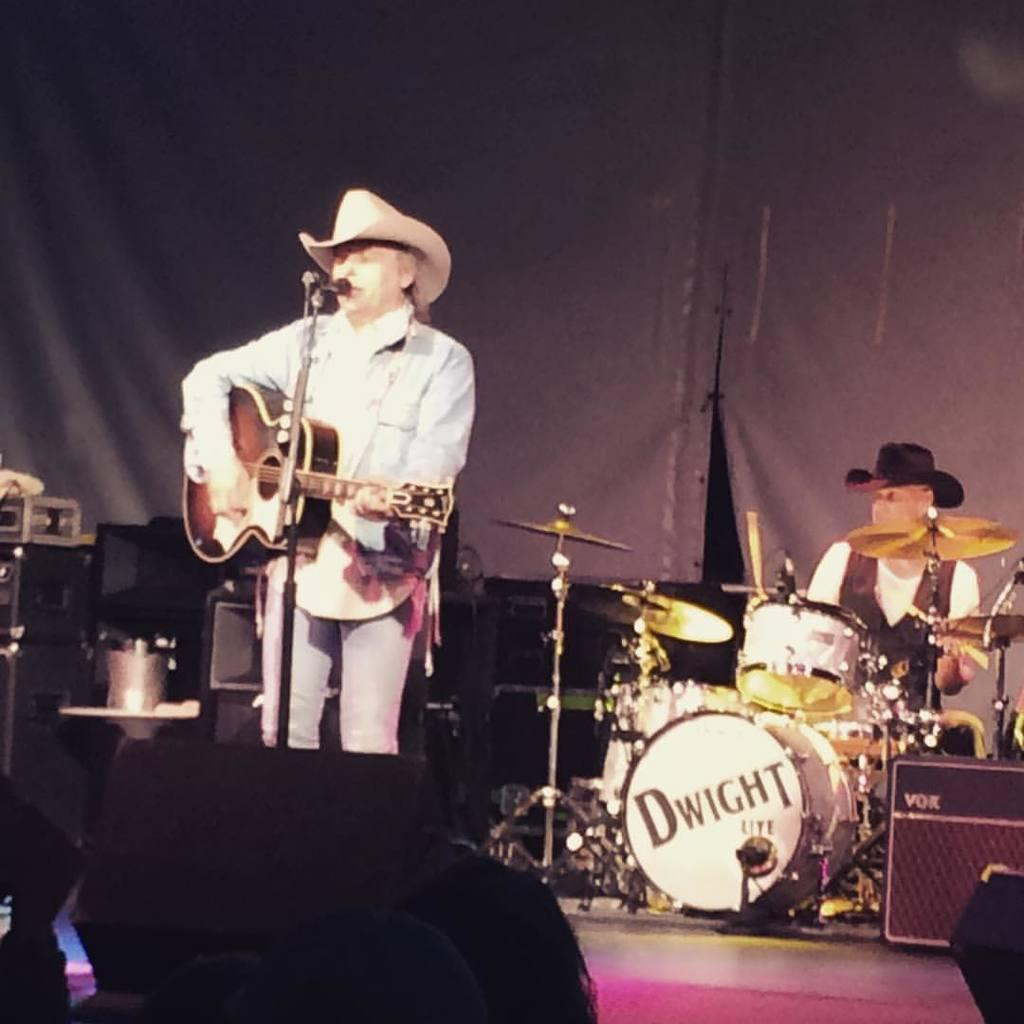What is the man in the image doing? The man is playing a guitar and singing. How is the man positioned in the image? The man is standing in the image. What object is the man using to amplify his voice? The man is in front of a microphone. What other activity is the man engaged in besides singing? The man is playing musical instruments. What type of toothpaste is the man using in the image? There is no toothpaste present in the image; the man is playing a guitar and singing. Is the man a writer in the image? There is no indication in the image that the man is a writer. 